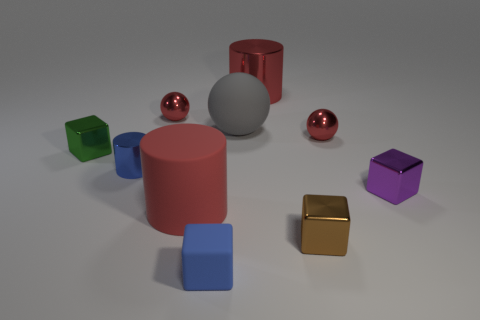Subtract all cubes. How many objects are left? 6 Subtract all matte things. Subtract all matte cylinders. How many objects are left? 6 Add 2 tiny green cubes. How many tiny green cubes are left? 3 Add 5 rubber objects. How many rubber objects exist? 8 Subtract 1 blue cubes. How many objects are left? 9 